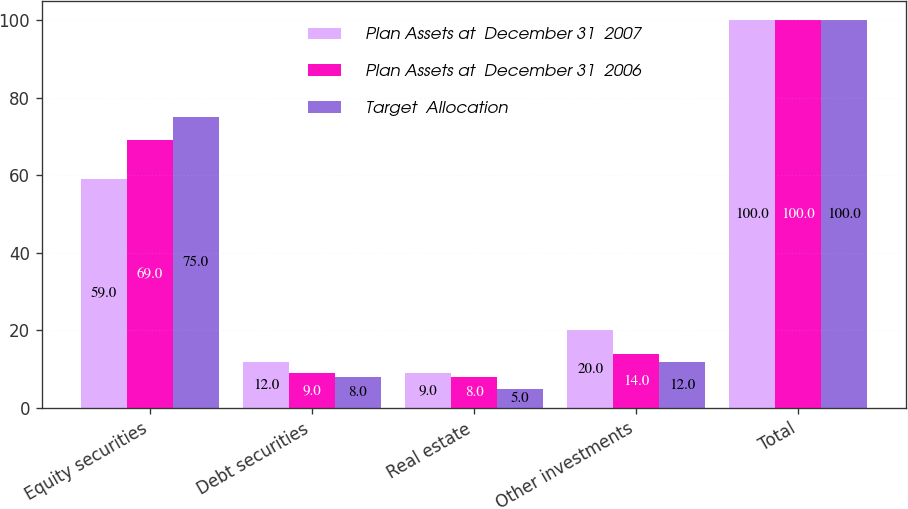Convert chart to OTSL. <chart><loc_0><loc_0><loc_500><loc_500><stacked_bar_chart><ecel><fcel>Equity securities<fcel>Debt securities<fcel>Real estate<fcel>Other investments<fcel>Total<nl><fcel>Plan Assets at  December 31  2007<fcel>59<fcel>12<fcel>9<fcel>20<fcel>100<nl><fcel>Plan Assets at  December 31  2006<fcel>69<fcel>9<fcel>8<fcel>14<fcel>100<nl><fcel>Target  Allocation<fcel>75<fcel>8<fcel>5<fcel>12<fcel>100<nl></chart> 